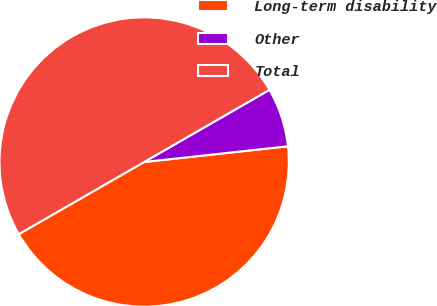<chart> <loc_0><loc_0><loc_500><loc_500><pie_chart><fcel>Long-term disability<fcel>Other<fcel>Total<nl><fcel>43.42%<fcel>6.58%<fcel>50.0%<nl></chart> 